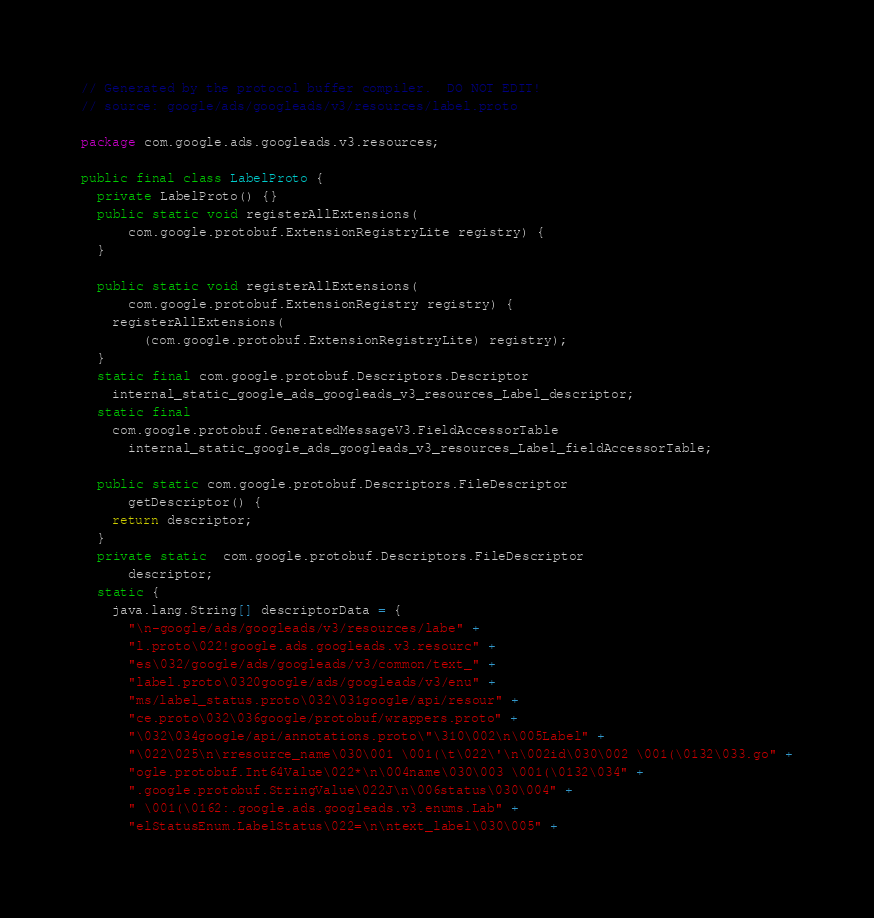<code> <loc_0><loc_0><loc_500><loc_500><_Java_>// Generated by the protocol buffer compiler.  DO NOT EDIT!
// source: google/ads/googleads/v3/resources/label.proto

package com.google.ads.googleads.v3.resources;

public final class LabelProto {
  private LabelProto() {}
  public static void registerAllExtensions(
      com.google.protobuf.ExtensionRegistryLite registry) {
  }

  public static void registerAllExtensions(
      com.google.protobuf.ExtensionRegistry registry) {
    registerAllExtensions(
        (com.google.protobuf.ExtensionRegistryLite) registry);
  }
  static final com.google.protobuf.Descriptors.Descriptor
    internal_static_google_ads_googleads_v3_resources_Label_descriptor;
  static final 
    com.google.protobuf.GeneratedMessageV3.FieldAccessorTable
      internal_static_google_ads_googleads_v3_resources_Label_fieldAccessorTable;

  public static com.google.protobuf.Descriptors.FileDescriptor
      getDescriptor() {
    return descriptor;
  }
  private static  com.google.protobuf.Descriptors.FileDescriptor
      descriptor;
  static {
    java.lang.String[] descriptorData = {
      "\n-google/ads/googleads/v3/resources/labe" +
      "l.proto\022!google.ads.googleads.v3.resourc" +
      "es\032/google/ads/googleads/v3/common/text_" +
      "label.proto\0320google/ads/googleads/v3/enu" +
      "ms/label_status.proto\032\031google/api/resour" +
      "ce.proto\032\036google/protobuf/wrappers.proto" +
      "\032\034google/api/annotations.proto\"\310\002\n\005Label" +
      "\022\025\n\rresource_name\030\001 \001(\t\022\'\n\002id\030\002 \001(\0132\033.go" +
      "ogle.protobuf.Int64Value\022*\n\004name\030\003 \001(\0132\034" +
      ".google.protobuf.StringValue\022J\n\006status\030\004" +
      " \001(\0162:.google.ads.googleads.v3.enums.Lab" +
      "elStatusEnum.LabelStatus\022=\n\ntext_label\030\005" +</code> 